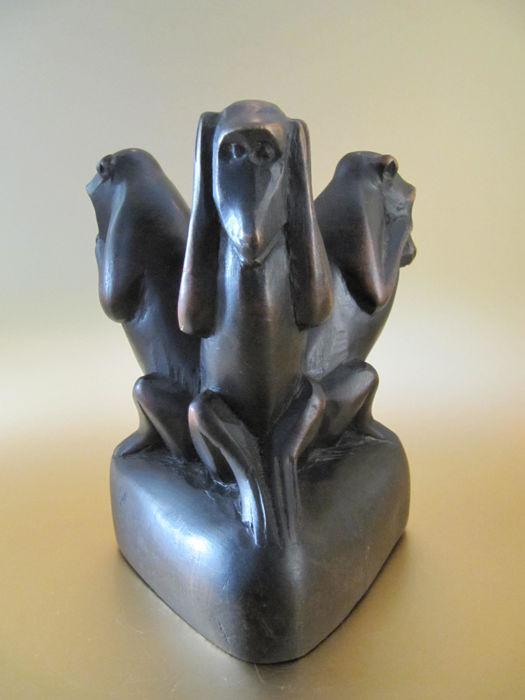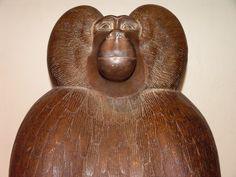The first image is the image on the left, the second image is the image on the right. Evaluate the accuracy of this statement regarding the images: "There is one statue that features one brown monkey and another statue that depicts three black monkeys in various poses.". Is it true? Answer yes or no. Yes. 